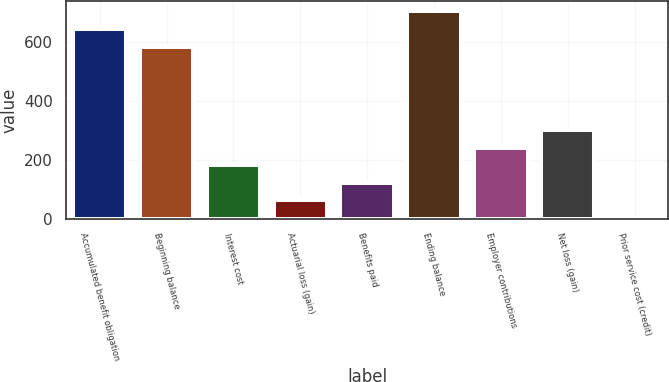<chart> <loc_0><loc_0><loc_500><loc_500><bar_chart><fcel>Accumulated benefit obligation<fcel>Beginning balance<fcel>Interest cost<fcel>Actuarial loss (gain)<fcel>Benefits paid<fcel>Ending balance<fcel>Employer contributions<fcel>Net loss (gain)<fcel>Prior service cost (credit)<nl><fcel>642.6<fcel>583<fcel>181.8<fcel>62.6<fcel>122.2<fcel>702.2<fcel>241.4<fcel>301<fcel>3<nl></chart> 